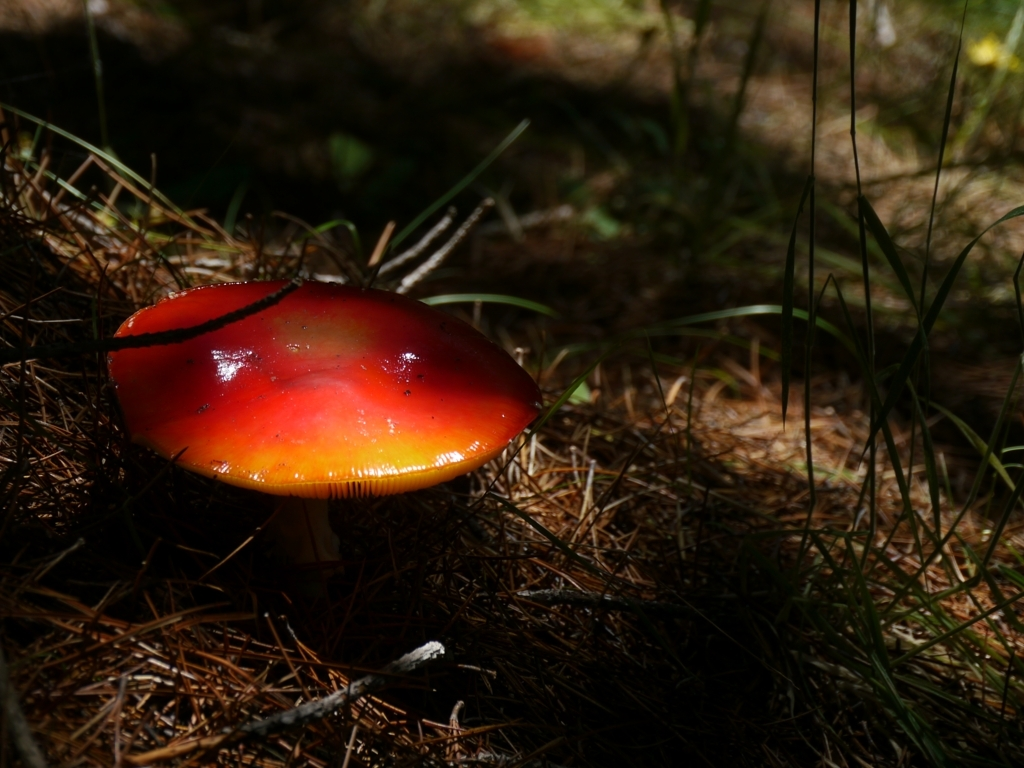How is the color contrast between the subject and the background? The color contrast in the image is quite striking. The subject, a bright red mushroom, stands out vividly against the muted tones of the forest floor and the dark background. Its vibrant cap captures the eye, providing a focal point amidst the surrounding natural textures. 